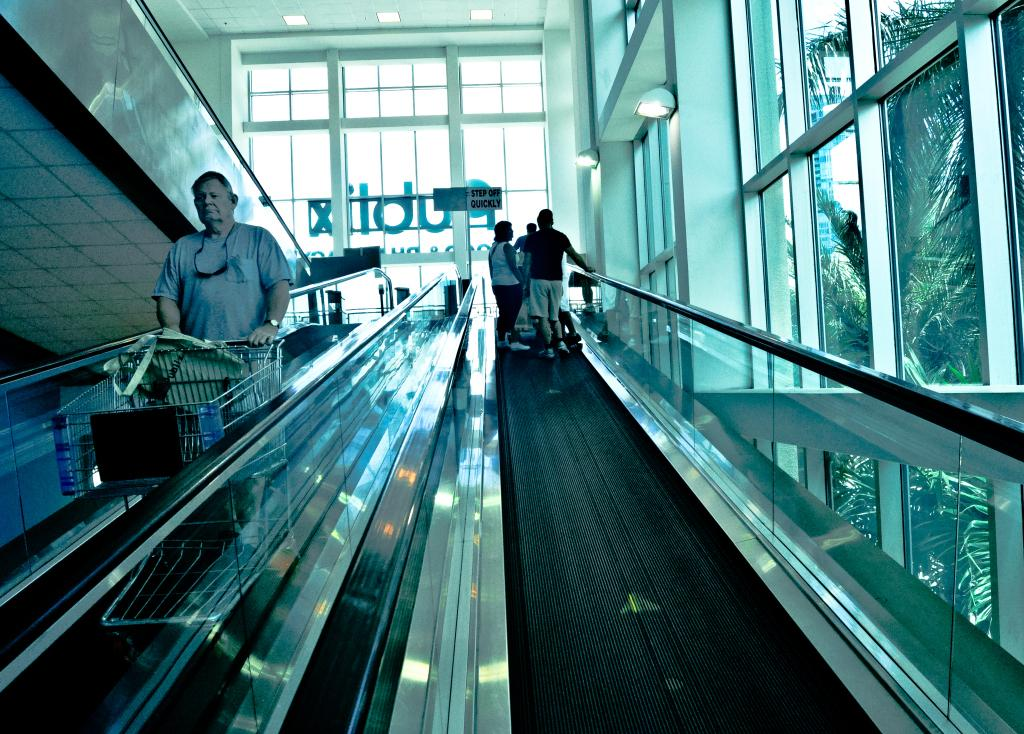Provide a one-sentence caption for the provided image. An escalator with a sign at the end that tells people to step off quickly. 